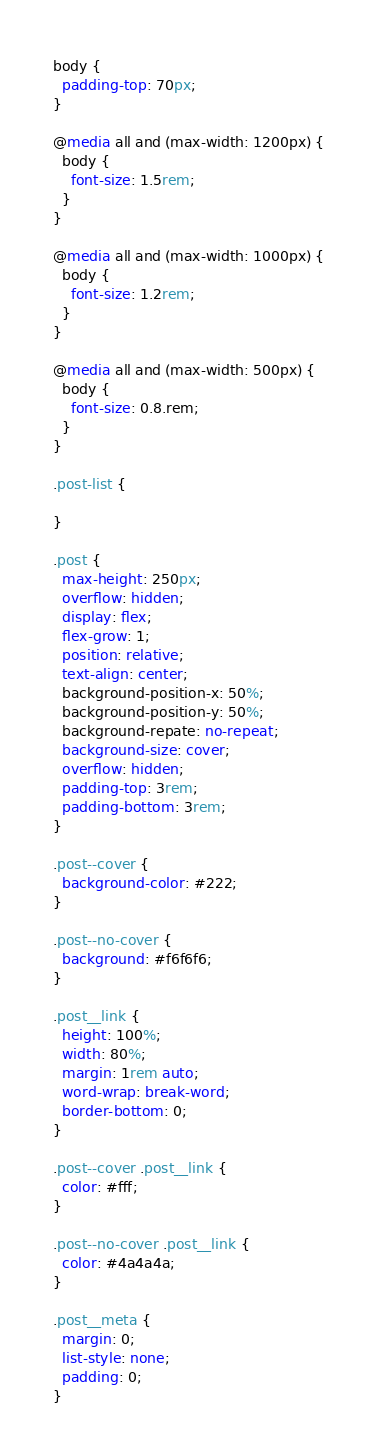Convert code to text. <code><loc_0><loc_0><loc_500><loc_500><_CSS_>body {
  padding-top: 70px;
}

@media all and (max-width: 1200px) {
  body {
    font-size: 1.5rem;
  }
}

@media all and (max-width: 1000px) {
  body {
    font-size: 1.2rem;
  }
}

@media all and (max-width: 500px) {
  body {
    font-size: 0.8.rem;
  }
}

.post-list {
  
}

.post {
  max-height: 250px;
  overflow: hidden;
  display: flex;
  flex-grow: 1;
  position: relative;
  text-align: center;
  background-position-x: 50%;
  background-position-y: 50%;
  background-repate: no-repeat;
  background-size: cover;
  overflow: hidden;
  padding-top: 3rem;
  padding-bottom: 3rem;
}

.post--cover {
  background-color: #222;
}

.post--no-cover {
  background: #f6f6f6;
}

.post__link {
  height: 100%;
  width: 80%;
  margin: 1rem auto;
  word-wrap: break-word;
  border-bottom: 0;
}

.post--cover .post__link {
  color: #fff;
}

.post--no-cover .post__link {
  color: #4a4a4a;
}

.post__meta {
  margin: 0;
  list-style: none;
  padding: 0;
}
</code> 